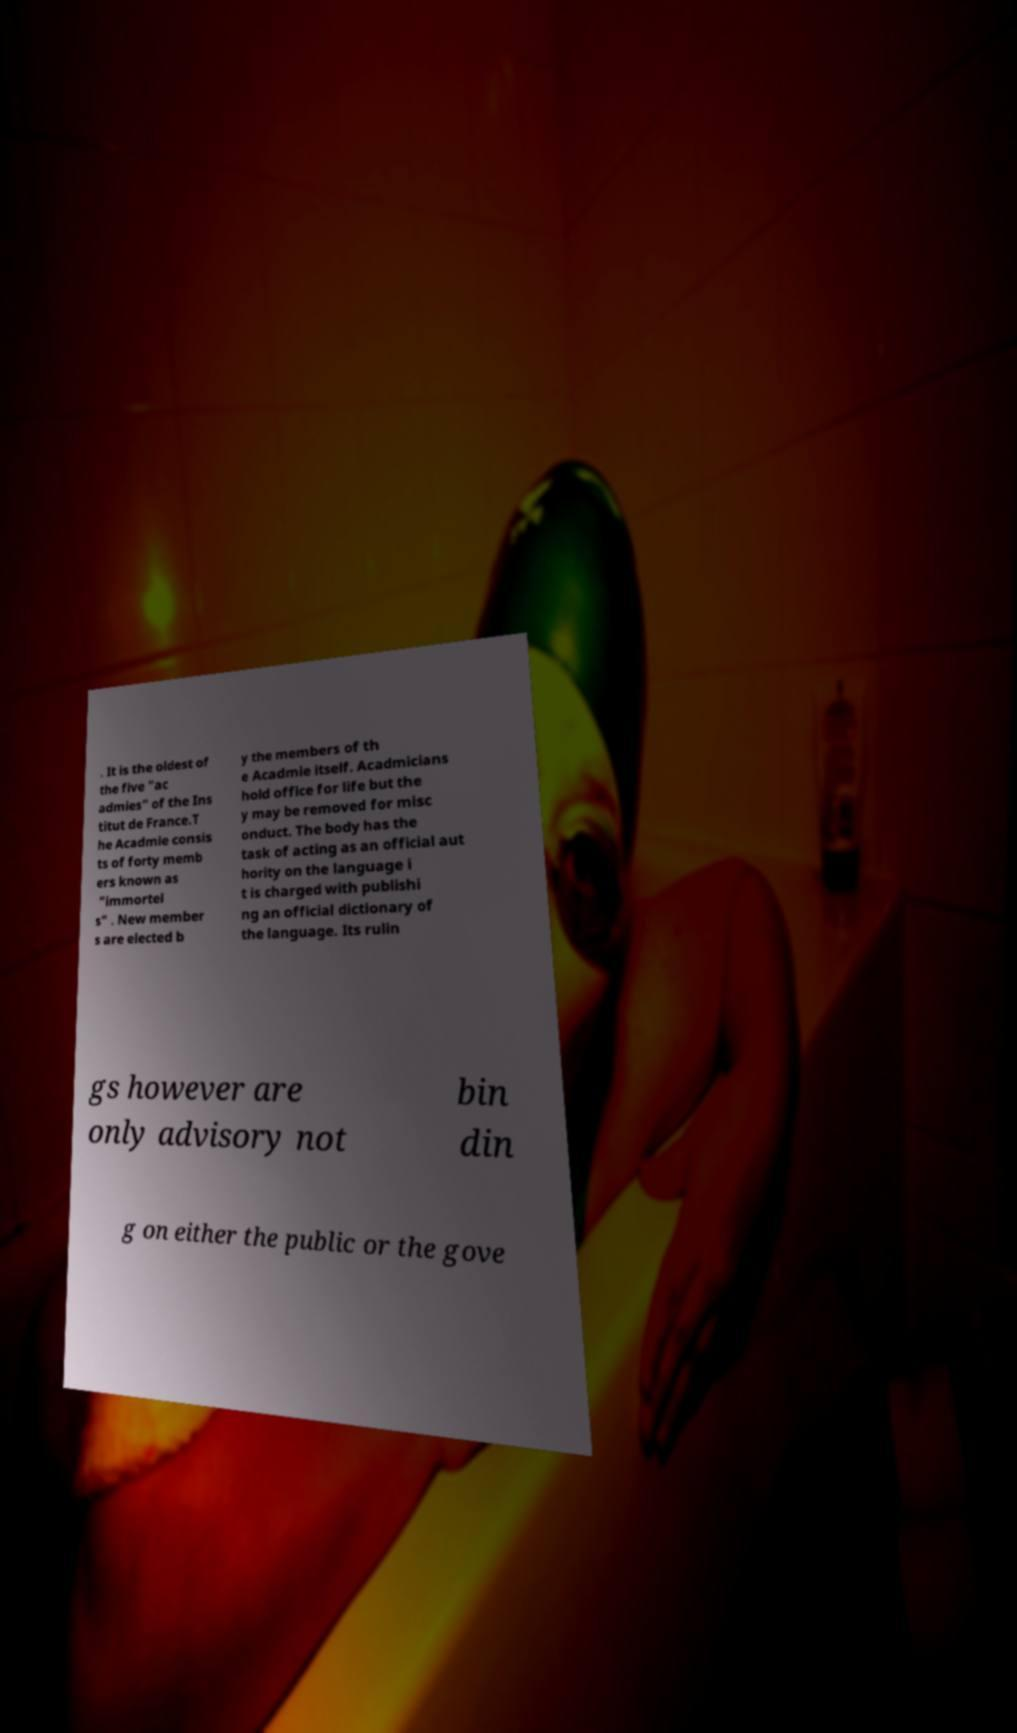What messages or text are displayed in this image? I need them in a readable, typed format. . It is the oldest of the five "ac admies" of the Ins titut de France.T he Acadmie consis ts of forty memb ers known as "immortel s" . New member s are elected b y the members of th e Acadmie itself. Acadmicians hold office for life but the y may be removed for misc onduct. The body has the task of acting as an official aut hority on the language i t is charged with publishi ng an official dictionary of the language. Its rulin gs however are only advisory not bin din g on either the public or the gove 